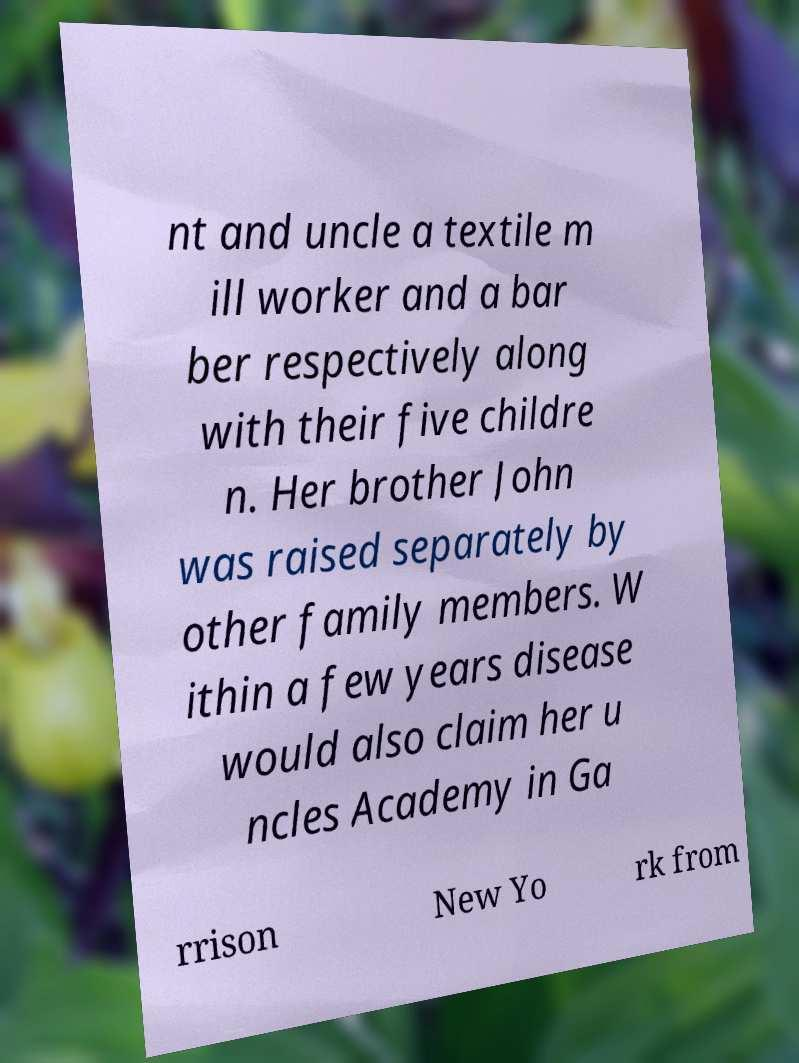What messages or text are displayed in this image? I need them in a readable, typed format. nt and uncle a textile m ill worker and a bar ber respectively along with their five childre n. Her brother John was raised separately by other family members. W ithin a few years disease would also claim her u ncles Academy in Ga rrison New Yo rk from 